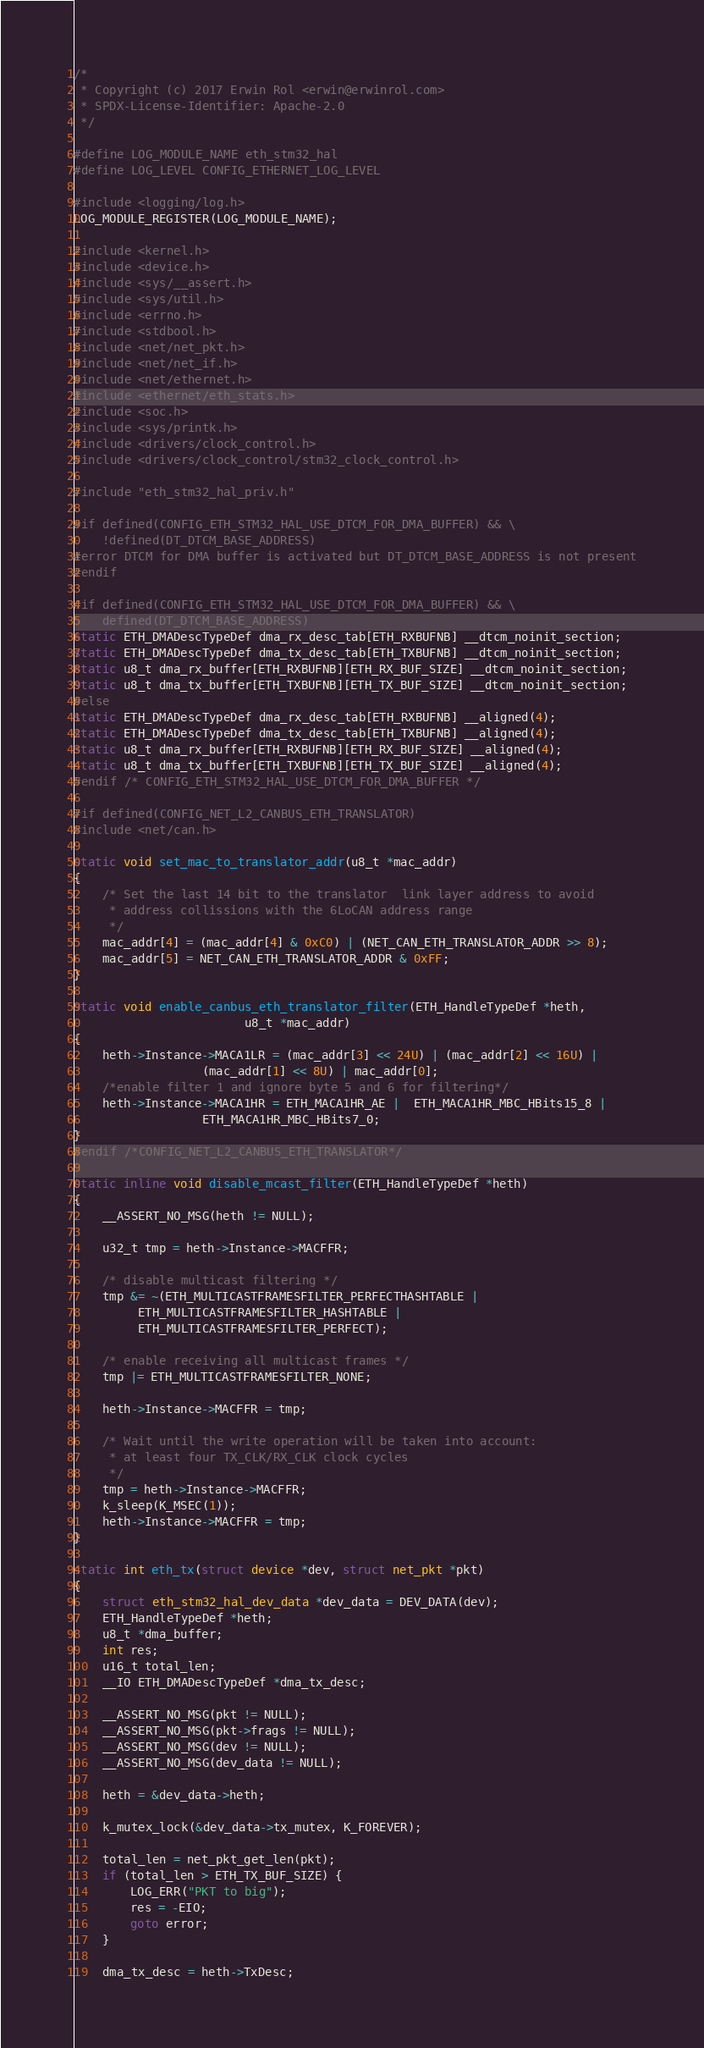<code> <loc_0><loc_0><loc_500><loc_500><_C_>/*
 * Copyright (c) 2017 Erwin Rol <erwin@erwinrol.com>
 * SPDX-License-Identifier: Apache-2.0
 */

#define LOG_MODULE_NAME eth_stm32_hal
#define LOG_LEVEL CONFIG_ETHERNET_LOG_LEVEL

#include <logging/log.h>
LOG_MODULE_REGISTER(LOG_MODULE_NAME);

#include <kernel.h>
#include <device.h>
#include <sys/__assert.h>
#include <sys/util.h>
#include <errno.h>
#include <stdbool.h>
#include <net/net_pkt.h>
#include <net/net_if.h>
#include <net/ethernet.h>
#include <ethernet/eth_stats.h>
#include <soc.h>
#include <sys/printk.h>
#include <drivers/clock_control.h>
#include <drivers/clock_control/stm32_clock_control.h>

#include "eth_stm32_hal_priv.h"

#if defined(CONFIG_ETH_STM32_HAL_USE_DTCM_FOR_DMA_BUFFER) && \
    !defined(DT_DTCM_BASE_ADDRESS)
#error DTCM for DMA buffer is activated but DT_DTCM_BASE_ADDRESS is not present
#endif

#if defined(CONFIG_ETH_STM32_HAL_USE_DTCM_FOR_DMA_BUFFER) && \
    defined(DT_DTCM_BASE_ADDRESS)
static ETH_DMADescTypeDef dma_rx_desc_tab[ETH_RXBUFNB] __dtcm_noinit_section;
static ETH_DMADescTypeDef dma_tx_desc_tab[ETH_TXBUFNB] __dtcm_noinit_section;
static u8_t dma_rx_buffer[ETH_RXBUFNB][ETH_RX_BUF_SIZE] __dtcm_noinit_section;
static u8_t dma_tx_buffer[ETH_TXBUFNB][ETH_TX_BUF_SIZE] __dtcm_noinit_section;
#else
static ETH_DMADescTypeDef dma_rx_desc_tab[ETH_RXBUFNB] __aligned(4);
static ETH_DMADescTypeDef dma_tx_desc_tab[ETH_TXBUFNB] __aligned(4);
static u8_t dma_rx_buffer[ETH_RXBUFNB][ETH_RX_BUF_SIZE] __aligned(4);
static u8_t dma_tx_buffer[ETH_TXBUFNB][ETH_TX_BUF_SIZE] __aligned(4);
#endif /* CONFIG_ETH_STM32_HAL_USE_DTCM_FOR_DMA_BUFFER */

#if defined(CONFIG_NET_L2_CANBUS_ETH_TRANSLATOR)
#include <net/can.h>

static void set_mac_to_translator_addr(u8_t *mac_addr)
{
	/* Set the last 14 bit to the translator  link layer address to avoid
	 * address collissions with the 6LoCAN address range
	 */
	mac_addr[4] = (mac_addr[4] & 0xC0) | (NET_CAN_ETH_TRANSLATOR_ADDR >> 8);
	mac_addr[5] = NET_CAN_ETH_TRANSLATOR_ADDR & 0xFF;
}

static void enable_canbus_eth_translator_filter(ETH_HandleTypeDef *heth,
						u8_t *mac_addr)
{
	heth->Instance->MACA1LR = (mac_addr[3] << 24U) | (mac_addr[2] << 16U) |
				  (mac_addr[1] << 8U) | mac_addr[0];
	/*enable filter 1 and ignore byte 5 and 6 for filtering*/
	heth->Instance->MACA1HR = ETH_MACA1HR_AE |  ETH_MACA1HR_MBC_HBits15_8 |
				  ETH_MACA1HR_MBC_HBits7_0;
}
#endif /*CONFIG_NET_L2_CANBUS_ETH_TRANSLATOR*/

static inline void disable_mcast_filter(ETH_HandleTypeDef *heth)
{
	__ASSERT_NO_MSG(heth != NULL);

	u32_t tmp = heth->Instance->MACFFR;

	/* disable multicast filtering */
	tmp &= ~(ETH_MULTICASTFRAMESFILTER_PERFECTHASHTABLE |
		 ETH_MULTICASTFRAMESFILTER_HASHTABLE |
		 ETH_MULTICASTFRAMESFILTER_PERFECT);

	/* enable receiving all multicast frames */
	tmp |= ETH_MULTICASTFRAMESFILTER_NONE;

	heth->Instance->MACFFR = tmp;

	/* Wait until the write operation will be taken into account:
	 * at least four TX_CLK/RX_CLK clock cycles
	 */
	tmp = heth->Instance->MACFFR;
	k_sleep(K_MSEC(1));
	heth->Instance->MACFFR = tmp;
}

static int eth_tx(struct device *dev, struct net_pkt *pkt)
{
	struct eth_stm32_hal_dev_data *dev_data = DEV_DATA(dev);
	ETH_HandleTypeDef *heth;
	u8_t *dma_buffer;
	int res;
	u16_t total_len;
	__IO ETH_DMADescTypeDef *dma_tx_desc;

	__ASSERT_NO_MSG(pkt != NULL);
	__ASSERT_NO_MSG(pkt->frags != NULL);
	__ASSERT_NO_MSG(dev != NULL);
	__ASSERT_NO_MSG(dev_data != NULL);

	heth = &dev_data->heth;

	k_mutex_lock(&dev_data->tx_mutex, K_FOREVER);

	total_len = net_pkt_get_len(pkt);
	if (total_len > ETH_TX_BUF_SIZE) {
		LOG_ERR("PKT to big");
		res = -EIO;
		goto error;
	}

	dma_tx_desc = heth->TxDesc;</code> 